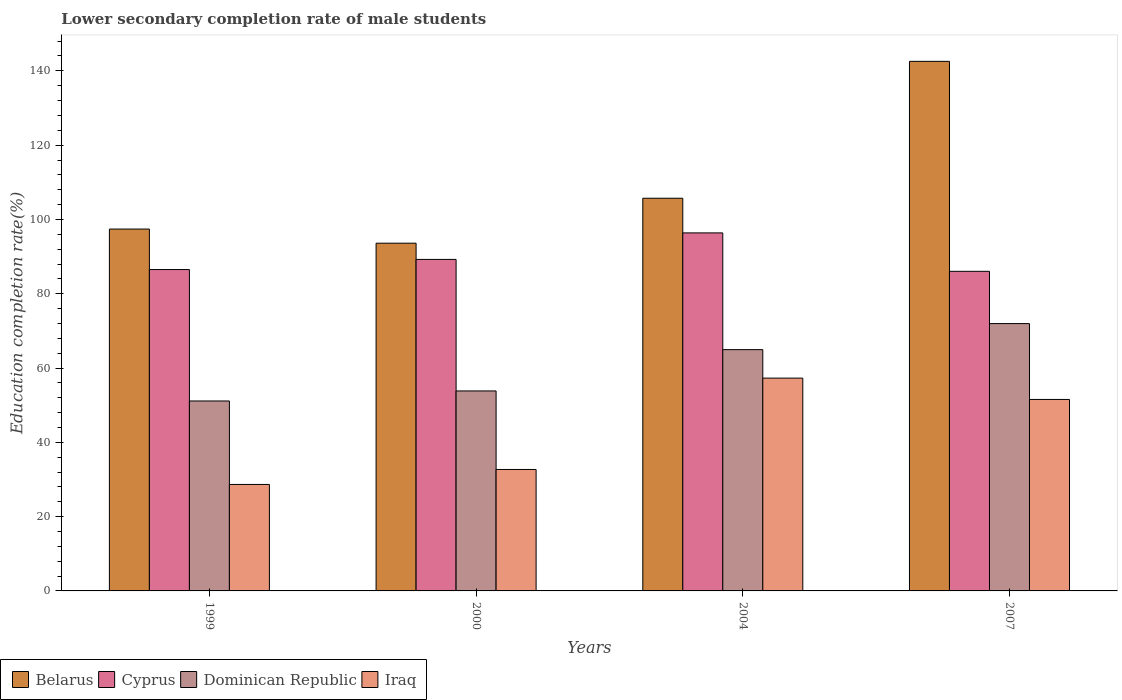How many groups of bars are there?
Your answer should be compact. 4. Are the number of bars on each tick of the X-axis equal?
Provide a succinct answer. Yes. How many bars are there on the 3rd tick from the right?
Ensure brevity in your answer.  4. In how many cases, is the number of bars for a given year not equal to the number of legend labels?
Offer a terse response. 0. What is the lower secondary completion rate of male students in Iraq in 2007?
Give a very brief answer. 51.54. Across all years, what is the maximum lower secondary completion rate of male students in Dominican Republic?
Give a very brief answer. 71.96. Across all years, what is the minimum lower secondary completion rate of male students in Cyprus?
Offer a very short reply. 86.03. What is the total lower secondary completion rate of male students in Dominican Republic in the graph?
Offer a terse response. 241.88. What is the difference between the lower secondary completion rate of male students in Dominican Republic in 2000 and that in 2007?
Keep it short and to the point. -18.13. What is the difference between the lower secondary completion rate of male students in Dominican Republic in 2007 and the lower secondary completion rate of male students in Iraq in 2000?
Your answer should be very brief. 39.27. What is the average lower secondary completion rate of male students in Iraq per year?
Make the answer very short. 42.55. In the year 2000, what is the difference between the lower secondary completion rate of male students in Iraq and lower secondary completion rate of male students in Cyprus?
Provide a short and direct response. -56.55. What is the ratio of the lower secondary completion rate of male students in Belarus in 2000 to that in 2007?
Your response must be concise. 0.66. Is the lower secondary completion rate of male students in Belarus in 2000 less than that in 2007?
Offer a very short reply. Yes. Is the difference between the lower secondary completion rate of male students in Iraq in 2000 and 2004 greater than the difference between the lower secondary completion rate of male students in Cyprus in 2000 and 2004?
Your answer should be very brief. No. What is the difference between the highest and the second highest lower secondary completion rate of male students in Belarus?
Ensure brevity in your answer.  36.85. What is the difference between the highest and the lowest lower secondary completion rate of male students in Dominican Republic?
Your answer should be very brief. 20.83. What does the 2nd bar from the left in 2000 represents?
Provide a short and direct response. Cyprus. What does the 2nd bar from the right in 2007 represents?
Your answer should be very brief. Dominican Republic. Is it the case that in every year, the sum of the lower secondary completion rate of male students in Iraq and lower secondary completion rate of male students in Dominican Republic is greater than the lower secondary completion rate of male students in Belarus?
Your answer should be compact. No. How many bars are there?
Offer a very short reply. 16. Does the graph contain any zero values?
Provide a succinct answer. No. Does the graph contain grids?
Provide a short and direct response. No. How are the legend labels stacked?
Make the answer very short. Horizontal. What is the title of the graph?
Keep it short and to the point. Lower secondary completion rate of male students. What is the label or title of the X-axis?
Keep it short and to the point. Years. What is the label or title of the Y-axis?
Offer a very short reply. Education completion rate(%). What is the Education completion rate(%) of Belarus in 1999?
Your response must be concise. 97.41. What is the Education completion rate(%) in Cyprus in 1999?
Provide a succinct answer. 86.51. What is the Education completion rate(%) in Dominican Republic in 1999?
Your answer should be very brief. 51.13. What is the Education completion rate(%) in Iraq in 1999?
Ensure brevity in your answer.  28.66. What is the Education completion rate(%) of Belarus in 2000?
Keep it short and to the point. 93.61. What is the Education completion rate(%) in Cyprus in 2000?
Make the answer very short. 89.24. What is the Education completion rate(%) in Dominican Republic in 2000?
Keep it short and to the point. 53.83. What is the Education completion rate(%) in Iraq in 2000?
Offer a terse response. 32.69. What is the Education completion rate(%) of Belarus in 2004?
Make the answer very short. 105.7. What is the Education completion rate(%) of Cyprus in 2004?
Offer a terse response. 96.38. What is the Education completion rate(%) of Dominican Republic in 2004?
Provide a short and direct response. 64.95. What is the Education completion rate(%) of Iraq in 2004?
Your answer should be compact. 57.28. What is the Education completion rate(%) of Belarus in 2007?
Keep it short and to the point. 142.56. What is the Education completion rate(%) of Cyprus in 2007?
Provide a succinct answer. 86.03. What is the Education completion rate(%) of Dominican Republic in 2007?
Keep it short and to the point. 71.96. What is the Education completion rate(%) of Iraq in 2007?
Offer a terse response. 51.54. Across all years, what is the maximum Education completion rate(%) in Belarus?
Give a very brief answer. 142.56. Across all years, what is the maximum Education completion rate(%) in Cyprus?
Provide a short and direct response. 96.38. Across all years, what is the maximum Education completion rate(%) in Dominican Republic?
Provide a short and direct response. 71.96. Across all years, what is the maximum Education completion rate(%) of Iraq?
Your answer should be compact. 57.28. Across all years, what is the minimum Education completion rate(%) of Belarus?
Provide a short and direct response. 93.61. Across all years, what is the minimum Education completion rate(%) in Cyprus?
Your answer should be very brief. 86.03. Across all years, what is the minimum Education completion rate(%) in Dominican Republic?
Keep it short and to the point. 51.13. Across all years, what is the minimum Education completion rate(%) in Iraq?
Ensure brevity in your answer.  28.66. What is the total Education completion rate(%) of Belarus in the graph?
Provide a succinct answer. 439.28. What is the total Education completion rate(%) of Cyprus in the graph?
Your response must be concise. 358.16. What is the total Education completion rate(%) of Dominican Republic in the graph?
Provide a succinct answer. 241.88. What is the total Education completion rate(%) of Iraq in the graph?
Keep it short and to the point. 170.18. What is the difference between the Education completion rate(%) in Belarus in 1999 and that in 2000?
Offer a terse response. 3.8. What is the difference between the Education completion rate(%) of Cyprus in 1999 and that in 2000?
Your response must be concise. -2.73. What is the difference between the Education completion rate(%) of Dominican Republic in 1999 and that in 2000?
Give a very brief answer. -2.7. What is the difference between the Education completion rate(%) in Iraq in 1999 and that in 2000?
Ensure brevity in your answer.  -4.03. What is the difference between the Education completion rate(%) in Belarus in 1999 and that in 2004?
Give a very brief answer. -8.29. What is the difference between the Education completion rate(%) in Cyprus in 1999 and that in 2004?
Provide a succinct answer. -9.87. What is the difference between the Education completion rate(%) in Dominican Republic in 1999 and that in 2004?
Keep it short and to the point. -13.82. What is the difference between the Education completion rate(%) of Iraq in 1999 and that in 2004?
Make the answer very short. -28.62. What is the difference between the Education completion rate(%) in Belarus in 1999 and that in 2007?
Give a very brief answer. -45.15. What is the difference between the Education completion rate(%) of Cyprus in 1999 and that in 2007?
Give a very brief answer. 0.48. What is the difference between the Education completion rate(%) in Dominican Republic in 1999 and that in 2007?
Ensure brevity in your answer.  -20.83. What is the difference between the Education completion rate(%) of Iraq in 1999 and that in 2007?
Provide a succinct answer. -22.88. What is the difference between the Education completion rate(%) in Belarus in 2000 and that in 2004?
Make the answer very short. -12.1. What is the difference between the Education completion rate(%) of Cyprus in 2000 and that in 2004?
Make the answer very short. -7.14. What is the difference between the Education completion rate(%) of Dominican Republic in 2000 and that in 2004?
Your answer should be compact. -11.12. What is the difference between the Education completion rate(%) of Iraq in 2000 and that in 2004?
Your answer should be compact. -24.59. What is the difference between the Education completion rate(%) in Belarus in 2000 and that in 2007?
Provide a succinct answer. -48.95. What is the difference between the Education completion rate(%) in Cyprus in 2000 and that in 2007?
Your answer should be compact. 3.21. What is the difference between the Education completion rate(%) in Dominican Republic in 2000 and that in 2007?
Your answer should be very brief. -18.13. What is the difference between the Education completion rate(%) of Iraq in 2000 and that in 2007?
Ensure brevity in your answer.  -18.85. What is the difference between the Education completion rate(%) in Belarus in 2004 and that in 2007?
Ensure brevity in your answer.  -36.85. What is the difference between the Education completion rate(%) of Cyprus in 2004 and that in 2007?
Your response must be concise. 10.34. What is the difference between the Education completion rate(%) in Dominican Republic in 2004 and that in 2007?
Make the answer very short. -7.01. What is the difference between the Education completion rate(%) of Iraq in 2004 and that in 2007?
Ensure brevity in your answer.  5.74. What is the difference between the Education completion rate(%) in Belarus in 1999 and the Education completion rate(%) in Cyprus in 2000?
Your answer should be compact. 8.17. What is the difference between the Education completion rate(%) in Belarus in 1999 and the Education completion rate(%) in Dominican Republic in 2000?
Ensure brevity in your answer.  43.58. What is the difference between the Education completion rate(%) in Belarus in 1999 and the Education completion rate(%) in Iraq in 2000?
Ensure brevity in your answer.  64.72. What is the difference between the Education completion rate(%) of Cyprus in 1999 and the Education completion rate(%) of Dominican Republic in 2000?
Your response must be concise. 32.68. What is the difference between the Education completion rate(%) of Cyprus in 1999 and the Education completion rate(%) of Iraq in 2000?
Ensure brevity in your answer.  53.82. What is the difference between the Education completion rate(%) in Dominican Republic in 1999 and the Education completion rate(%) in Iraq in 2000?
Offer a terse response. 18.44. What is the difference between the Education completion rate(%) in Belarus in 1999 and the Education completion rate(%) in Cyprus in 2004?
Ensure brevity in your answer.  1.03. What is the difference between the Education completion rate(%) in Belarus in 1999 and the Education completion rate(%) in Dominican Republic in 2004?
Make the answer very short. 32.46. What is the difference between the Education completion rate(%) of Belarus in 1999 and the Education completion rate(%) of Iraq in 2004?
Ensure brevity in your answer.  40.13. What is the difference between the Education completion rate(%) of Cyprus in 1999 and the Education completion rate(%) of Dominican Republic in 2004?
Make the answer very short. 21.55. What is the difference between the Education completion rate(%) in Cyprus in 1999 and the Education completion rate(%) in Iraq in 2004?
Give a very brief answer. 29.23. What is the difference between the Education completion rate(%) of Dominican Republic in 1999 and the Education completion rate(%) of Iraq in 2004?
Offer a very short reply. -6.15. What is the difference between the Education completion rate(%) in Belarus in 1999 and the Education completion rate(%) in Cyprus in 2007?
Give a very brief answer. 11.38. What is the difference between the Education completion rate(%) of Belarus in 1999 and the Education completion rate(%) of Dominican Republic in 2007?
Ensure brevity in your answer.  25.45. What is the difference between the Education completion rate(%) of Belarus in 1999 and the Education completion rate(%) of Iraq in 2007?
Ensure brevity in your answer.  45.87. What is the difference between the Education completion rate(%) in Cyprus in 1999 and the Education completion rate(%) in Dominican Republic in 2007?
Ensure brevity in your answer.  14.55. What is the difference between the Education completion rate(%) in Cyprus in 1999 and the Education completion rate(%) in Iraq in 2007?
Provide a short and direct response. 34.97. What is the difference between the Education completion rate(%) of Dominican Republic in 1999 and the Education completion rate(%) of Iraq in 2007?
Offer a very short reply. -0.41. What is the difference between the Education completion rate(%) in Belarus in 2000 and the Education completion rate(%) in Cyprus in 2004?
Give a very brief answer. -2.77. What is the difference between the Education completion rate(%) of Belarus in 2000 and the Education completion rate(%) of Dominican Republic in 2004?
Provide a short and direct response. 28.65. What is the difference between the Education completion rate(%) in Belarus in 2000 and the Education completion rate(%) in Iraq in 2004?
Offer a terse response. 36.32. What is the difference between the Education completion rate(%) in Cyprus in 2000 and the Education completion rate(%) in Dominican Republic in 2004?
Keep it short and to the point. 24.28. What is the difference between the Education completion rate(%) of Cyprus in 2000 and the Education completion rate(%) of Iraq in 2004?
Provide a succinct answer. 31.96. What is the difference between the Education completion rate(%) in Dominican Republic in 2000 and the Education completion rate(%) in Iraq in 2004?
Your response must be concise. -3.45. What is the difference between the Education completion rate(%) in Belarus in 2000 and the Education completion rate(%) in Cyprus in 2007?
Offer a very short reply. 7.57. What is the difference between the Education completion rate(%) of Belarus in 2000 and the Education completion rate(%) of Dominican Republic in 2007?
Your answer should be compact. 21.65. What is the difference between the Education completion rate(%) of Belarus in 2000 and the Education completion rate(%) of Iraq in 2007?
Provide a short and direct response. 42.06. What is the difference between the Education completion rate(%) of Cyprus in 2000 and the Education completion rate(%) of Dominican Republic in 2007?
Offer a terse response. 17.28. What is the difference between the Education completion rate(%) in Cyprus in 2000 and the Education completion rate(%) in Iraq in 2007?
Ensure brevity in your answer.  37.69. What is the difference between the Education completion rate(%) of Dominican Republic in 2000 and the Education completion rate(%) of Iraq in 2007?
Give a very brief answer. 2.29. What is the difference between the Education completion rate(%) in Belarus in 2004 and the Education completion rate(%) in Cyprus in 2007?
Offer a terse response. 19.67. What is the difference between the Education completion rate(%) of Belarus in 2004 and the Education completion rate(%) of Dominican Republic in 2007?
Your answer should be very brief. 33.74. What is the difference between the Education completion rate(%) of Belarus in 2004 and the Education completion rate(%) of Iraq in 2007?
Ensure brevity in your answer.  54.16. What is the difference between the Education completion rate(%) in Cyprus in 2004 and the Education completion rate(%) in Dominican Republic in 2007?
Ensure brevity in your answer.  24.41. What is the difference between the Education completion rate(%) in Cyprus in 2004 and the Education completion rate(%) in Iraq in 2007?
Your answer should be compact. 44.83. What is the difference between the Education completion rate(%) of Dominican Republic in 2004 and the Education completion rate(%) of Iraq in 2007?
Keep it short and to the point. 13.41. What is the average Education completion rate(%) in Belarus per year?
Offer a terse response. 109.82. What is the average Education completion rate(%) in Cyprus per year?
Give a very brief answer. 89.54. What is the average Education completion rate(%) in Dominican Republic per year?
Provide a short and direct response. 60.47. What is the average Education completion rate(%) in Iraq per year?
Your response must be concise. 42.55. In the year 1999, what is the difference between the Education completion rate(%) of Belarus and Education completion rate(%) of Cyprus?
Your answer should be very brief. 10.9. In the year 1999, what is the difference between the Education completion rate(%) of Belarus and Education completion rate(%) of Dominican Republic?
Keep it short and to the point. 46.28. In the year 1999, what is the difference between the Education completion rate(%) of Belarus and Education completion rate(%) of Iraq?
Ensure brevity in your answer.  68.75. In the year 1999, what is the difference between the Education completion rate(%) of Cyprus and Education completion rate(%) of Dominican Republic?
Make the answer very short. 35.38. In the year 1999, what is the difference between the Education completion rate(%) of Cyprus and Education completion rate(%) of Iraq?
Your answer should be very brief. 57.85. In the year 1999, what is the difference between the Education completion rate(%) of Dominican Republic and Education completion rate(%) of Iraq?
Offer a terse response. 22.47. In the year 2000, what is the difference between the Education completion rate(%) in Belarus and Education completion rate(%) in Cyprus?
Make the answer very short. 4.37. In the year 2000, what is the difference between the Education completion rate(%) in Belarus and Education completion rate(%) in Dominican Republic?
Keep it short and to the point. 39.77. In the year 2000, what is the difference between the Education completion rate(%) in Belarus and Education completion rate(%) in Iraq?
Your response must be concise. 60.92. In the year 2000, what is the difference between the Education completion rate(%) in Cyprus and Education completion rate(%) in Dominican Republic?
Keep it short and to the point. 35.41. In the year 2000, what is the difference between the Education completion rate(%) of Cyprus and Education completion rate(%) of Iraq?
Offer a terse response. 56.55. In the year 2000, what is the difference between the Education completion rate(%) of Dominican Republic and Education completion rate(%) of Iraq?
Make the answer very short. 21.14. In the year 2004, what is the difference between the Education completion rate(%) in Belarus and Education completion rate(%) in Cyprus?
Your answer should be very brief. 9.33. In the year 2004, what is the difference between the Education completion rate(%) in Belarus and Education completion rate(%) in Dominican Republic?
Offer a very short reply. 40.75. In the year 2004, what is the difference between the Education completion rate(%) of Belarus and Education completion rate(%) of Iraq?
Make the answer very short. 48.42. In the year 2004, what is the difference between the Education completion rate(%) in Cyprus and Education completion rate(%) in Dominican Republic?
Keep it short and to the point. 31.42. In the year 2004, what is the difference between the Education completion rate(%) of Cyprus and Education completion rate(%) of Iraq?
Make the answer very short. 39.09. In the year 2004, what is the difference between the Education completion rate(%) of Dominican Republic and Education completion rate(%) of Iraq?
Provide a succinct answer. 7.67. In the year 2007, what is the difference between the Education completion rate(%) in Belarus and Education completion rate(%) in Cyprus?
Your response must be concise. 56.52. In the year 2007, what is the difference between the Education completion rate(%) in Belarus and Education completion rate(%) in Dominican Republic?
Give a very brief answer. 70.59. In the year 2007, what is the difference between the Education completion rate(%) of Belarus and Education completion rate(%) of Iraq?
Make the answer very short. 91.01. In the year 2007, what is the difference between the Education completion rate(%) in Cyprus and Education completion rate(%) in Dominican Republic?
Keep it short and to the point. 14.07. In the year 2007, what is the difference between the Education completion rate(%) in Cyprus and Education completion rate(%) in Iraq?
Your answer should be compact. 34.49. In the year 2007, what is the difference between the Education completion rate(%) in Dominican Republic and Education completion rate(%) in Iraq?
Offer a very short reply. 20.42. What is the ratio of the Education completion rate(%) of Belarus in 1999 to that in 2000?
Your response must be concise. 1.04. What is the ratio of the Education completion rate(%) of Cyprus in 1999 to that in 2000?
Your answer should be compact. 0.97. What is the ratio of the Education completion rate(%) in Dominican Republic in 1999 to that in 2000?
Your response must be concise. 0.95. What is the ratio of the Education completion rate(%) in Iraq in 1999 to that in 2000?
Keep it short and to the point. 0.88. What is the ratio of the Education completion rate(%) of Belarus in 1999 to that in 2004?
Your answer should be very brief. 0.92. What is the ratio of the Education completion rate(%) in Cyprus in 1999 to that in 2004?
Make the answer very short. 0.9. What is the ratio of the Education completion rate(%) of Dominican Republic in 1999 to that in 2004?
Ensure brevity in your answer.  0.79. What is the ratio of the Education completion rate(%) of Iraq in 1999 to that in 2004?
Ensure brevity in your answer.  0.5. What is the ratio of the Education completion rate(%) of Belarus in 1999 to that in 2007?
Keep it short and to the point. 0.68. What is the ratio of the Education completion rate(%) in Dominican Republic in 1999 to that in 2007?
Your answer should be compact. 0.71. What is the ratio of the Education completion rate(%) of Iraq in 1999 to that in 2007?
Give a very brief answer. 0.56. What is the ratio of the Education completion rate(%) of Belarus in 2000 to that in 2004?
Keep it short and to the point. 0.89. What is the ratio of the Education completion rate(%) of Cyprus in 2000 to that in 2004?
Keep it short and to the point. 0.93. What is the ratio of the Education completion rate(%) in Dominican Republic in 2000 to that in 2004?
Provide a succinct answer. 0.83. What is the ratio of the Education completion rate(%) in Iraq in 2000 to that in 2004?
Offer a terse response. 0.57. What is the ratio of the Education completion rate(%) of Belarus in 2000 to that in 2007?
Give a very brief answer. 0.66. What is the ratio of the Education completion rate(%) of Cyprus in 2000 to that in 2007?
Give a very brief answer. 1.04. What is the ratio of the Education completion rate(%) in Dominican Republic in 2000 to that in 2007?
Provide a short and direct response. 0.75. What is the ratio of the Education completion rate(%) in Iraq in 2000 to that in 2007?
Make the answer very short. 0.63. What is the ratio of the Education completion rate(%) of Belarus in 2004 to that in 2007?
Provide a short and direct response. 0.74. What is the ratio of the Education completion rate(%) in Cyprus in 2004 to that in 2007?
Ensure brevity in your answer.  1.12. What is the ratio of the Education completion rate(%) of Dominican Republic in 2004 to that in 2007?
Keep it short and to the point. 0.9. What is the ratio of the Education completion rate(%) in Iraq in 2004 to that in 2007?
Your answer should be compact. 1.11. What is the difference between the highest and the second highest Education completion rate(%) of Belarus?
Make the answer very short. 36.85. What is the difference between the highest and the second highest Education completion rate(%) in Cyprus?
Keep it short and to the point. 7.14. What is the difference between the highest and the second highest Education completion rate(%) of Dominican Republic?
Make the answer very short. 7.01. What is the difference between the highest and the second highest Education completion rate(%) of Iraq?
Keep it short and to the point. 5.74. What is the difference between the highest and the lowest Education completion rate(%) of Belarus?
Offer a very short reply. 48.95. What is the difference between the highest and the lowest Education completion rate(%) in Cyprus?
Offer a terse response. 10.34. What is the difference between the highest and the lowest Education completion rate(%) of Dominican Republic?
Keep it short and to the point. 20.83. What is the difference between the highest and the lowest Education completion rate(%) of Iraq?
Your answer should be compact. 28.62. 